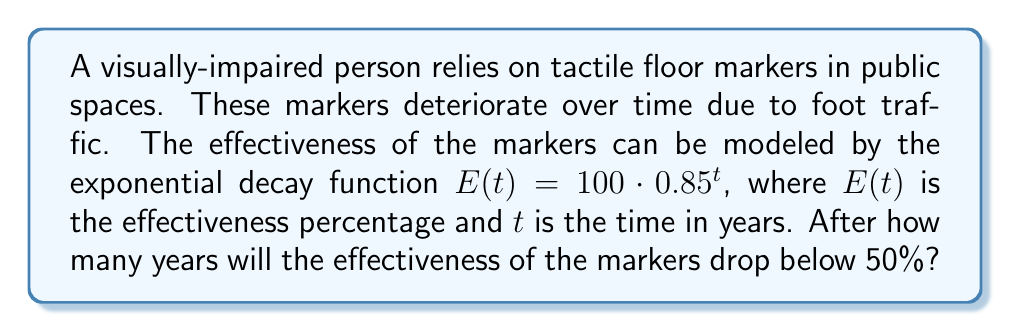Could you help me with this problem? To solve this problem, we need to use logarithms to analyze the exponential decay function. Let's approach this step-by-step:

1) We want to find $t$ when $E(t) < 50$. So, we set up the equation:
   
   $50 = 100 \cdot 0.85^t$

2) Divide both sides by 100:
   
   $0.5 = 0.85^t$

3) To solve for $t$, we need to take the logarithm of both sides. We can use any base for the logarithm, but it's convenient to use base 0.85 to cancel out the exponent:

   $\log_{0.85}(0.5) = \log_{0.85}(0.85^t)$

4) The right side simplifies to $t$:

   $\log_{0.85}(0.5) = t$

5) To calculate this, we can use the change of base formula:

   $t = \frac{\log(0.5)}{\log(0.85)}$

6) Using a calculator (or computer):

   $t \approx 4.27$ years

7) Since we're looking for when the effectiveness drops below 50%, we need to round up to the next whole year.
Answer: The effectiveness of the tactile floor markers will drop below 50% after 5 years. 